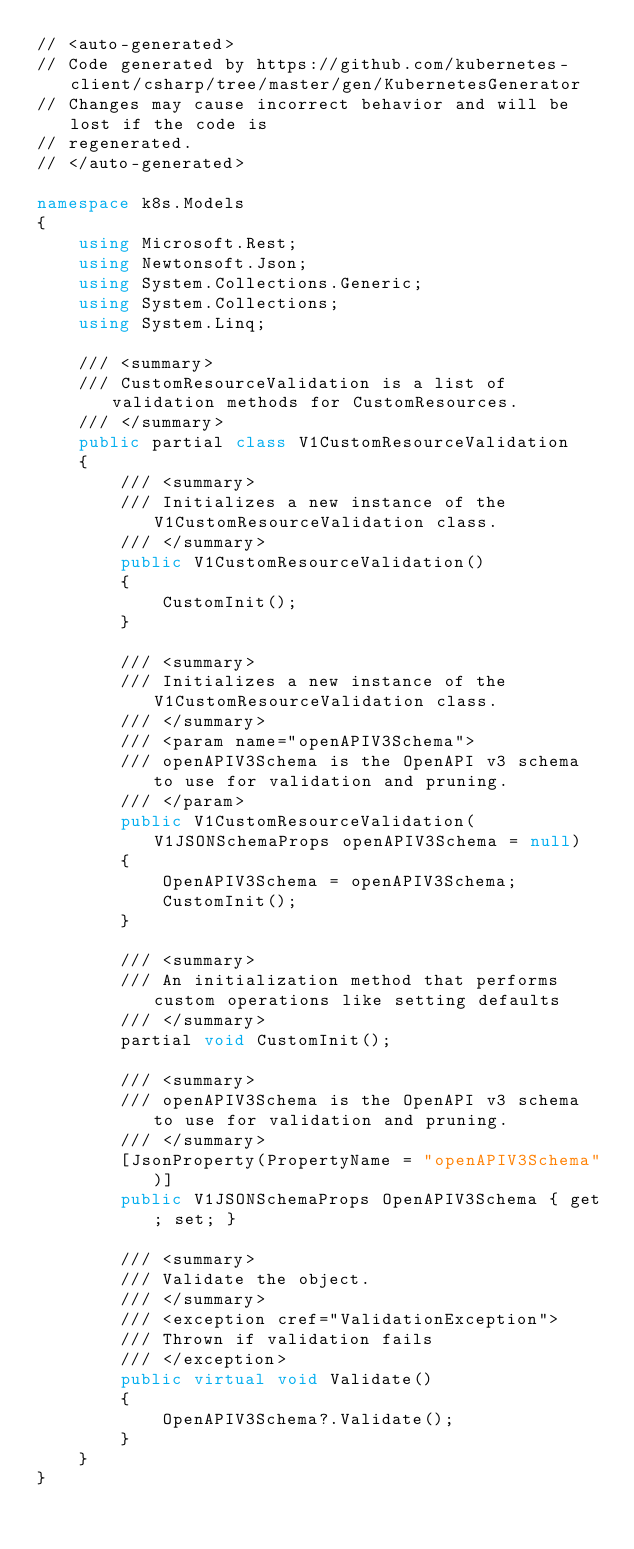<code> <loc_0><loc_0><loc_500><loc_500><_C#_>// <auto-generated>
// Code generated by https://github.com/kubernetes-client/csharp/tree/master/gen/KubernetesGenerator
// Changes may cause incorrect behavior and will be lost if the code is
// regenerated.
// </auto-generated>

namespace k8s.Models
{
    using Microsoft.Rest;
    using Newtonsoft.Json;
    using System.Collections.Generic;
    using System.Collections;
    using System.Linq;

    /// <summary>
    /// CustomResourceValidation is a list of validation methods for CustomResources.
    /// </summary>
    public partial class V1CustomResourceValidation
    {
        /// <summary>
        /// Initializes a new instance of the V1CustomResourceValidation class.
        /// </summary>
        public V1CustomResourceValidation()
        {
            CustomInit();
        }

        /// <summary>
        /// Initializes a new instance of the V1CustomResourceValidation class.
        /// </summary>
        /// <param name="openAPIV3Schema">
        /// openAPIV3Schema is the OpenAPI v3 schema to use for validation and pruning.
        /// </param>
        public V1CustomResourceValidation(V1JSONSchemaProps openAPIV3Schema = null)
        {
            OpenAPIV3Schema = openAPIV3Schema;
            CustomInit();
        }

        /// <summary>
        /// An initialization method that performs custom operations like setting defaults
        /// </summary>
        partial void CustomInit();

        /// <summary>
        /// openAPIV3Schema is the OpenAPI v3 schema to use for validation and pruning.
        /// </summary>
        [JsonProperty(PropertyName = "openAPIV3Schema")]
        public V1JSONSchemaProps OpenAPIV3Schema { get; set; }

        /// <summary>
        /// Validate the object.
        /// </summary>
        /// <exception cref="ValidationException">
        /// Thrown if validation fails
        /// </exception>
        public virtual void Validate()
        {
            OpenAPIV3Schema?.Validate();
        }
    }
}
</code> 